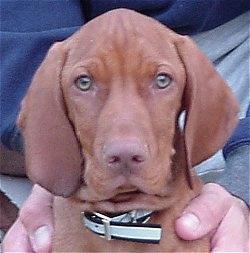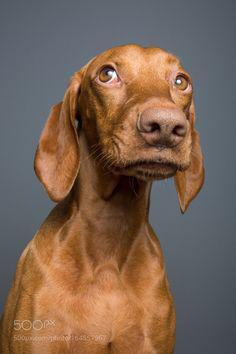The first image is the image on the left, the second image is the image on the right. For the images shown, is this caption "there are two dogs in the image pair" true? Answer yes or no. Yes. The first image is the image on the left, the second image is the image on the right. For the images shown, is this caption "The left image contains at least two dogs." true? Answer yes or no. No. 